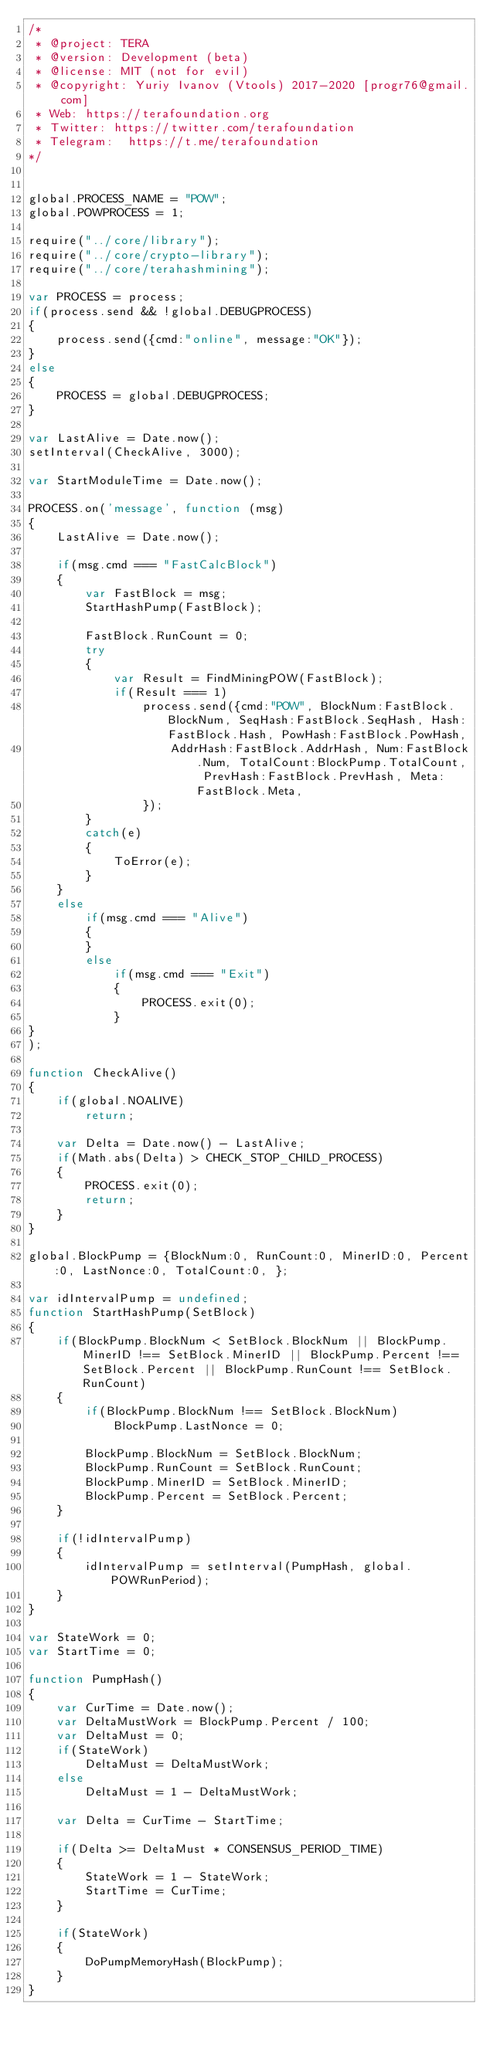Convert code to text. <code><loc_0><loc_0><loc_500><loc_500><_JavaScript_>/*
 * @project: TERA
 * @version: Development (beta)
 * @license: MIT (not for evil)
 * @copyright: Yuriy Ivanov (Vtools) 2017-2020 [progr76@gmail.com]
 * Web: https://terafoundation.org
 * Twitter: https://twitter.com/terafoundation
 * Telegram:  https://t.me/terafoundation
*/


global.PROCESS_NAME = "POW";
global.POWPROCESS = 1;

require("../core/library");
require("../core/crypto-library");
require("../core/terahashmining");

var PROCESS = process;
if(process.send && !global.DEBUGPROCESS)
{
    process.send({cmd:"online", message:"OK"});
}
else
{
    PROCESS = global.DEBUGPROCESS;
}

var LastAlive = Date.now();
setInterval(CheckAlive, 3000);

var StartModuleTime = Date.now();

PROCESS.on('message', function (msg)
{
    LastAlive = Date.now();
    
    if(msg.cmd === "FastCalcBlock")
    {
        var FastBlock = msg;
        StartHashPump(FastBlock);
        
        FastBlock.RunCount = 0;
        try
        {
            var Result = FindMiningPOW(FastBlock);
            if(Result === 1)
                process.send({cmd:"POW", BlockNum:FastBlock.BlockNum, SeqHash:FastBlock.SeqHash, Hash:FastBlock.Hash, PowHash:FastBlock.PowHash,
                    AddrHash:FastBlock.AddrHash, Num:FastBlock.Num, TotalCount:BlockPump.TotalCount, PrevHash:FastBlock.PrevHash, Meta:FastBlock.Meta,
                });
        }
        catch(e)
        {
            ToError(e);
        }
    }
    else
        if(msg.cmd === "Alive")
        {
        }
        else
            if(msg.cmd === "Exit")
            {
                PROCESS.exit(0);
            }
}
);

function CheckAlive()
{
    if(global.NOALIVE)
        return;
    
    var Delta = Date.now() - LastAlive;
    if(Math.abs(Delta) > CHECK_STOP_CHILD_PROCESS)
    {
        PROCESS.exit(0);
        return;
    }
}

global.BlockPump = {BlockNum:0, RunCount:0, MinerID:0, Percent:0, LastNonce:0, TotalCount:0, };

var idIntervalPump = undefined;
function StartHashPump(SetBlock)
{
    if(BlockPump.BlockNum < SetBlock.BlockNum || BlockPump.MinerID !== SetBlock.MinerID || BlockPump.Percent !== SetBlock.Percent || BlockPump.RunCount !== SetBlock.RunCount)
    {
        if(BlockPump.BlockNum !== SetBlock.BlockNum)
            BlockPump.LastNonce = 0;
        
        BlockPump.BlockNum = SetBlock.BlockNum;
        BlockPump.RunCount = SetBlock.RunCount;
        BlockPump.MinerID = SetBlock.MinerID;
        BlockPump.Percent = SetBlock.Percent;
    }
    
    if(!idIntervalPump)
    {
        idIntervalPump = setInterval(PumpHash, global.POWRunPeriod);
    }
}

var StateWork = 0;
var StartTime = 0;

function PumpHash()
{
    var CurTime = Date.now();
    var DeltaMustWork = BlockPump.Percent / 100;
    var DeltaMust = 0;
    if(StateWork)
        DeltaMust = DeltaMustWork;
    else
        DeltaMust = 1 - DeltaMustWork;
    
    var Delta = CurTime - StartTime;
    
    if(Delta >= DeltaMust * CONSENSUS_PERIOD_TIME)
    {
        StateWork = 1 - StateWork;
        StartTime = CurTime;
    }
    
    if(StateWork)
    {
        DoPumpMemoryHash(BlockPump);
    }
}
</code> 